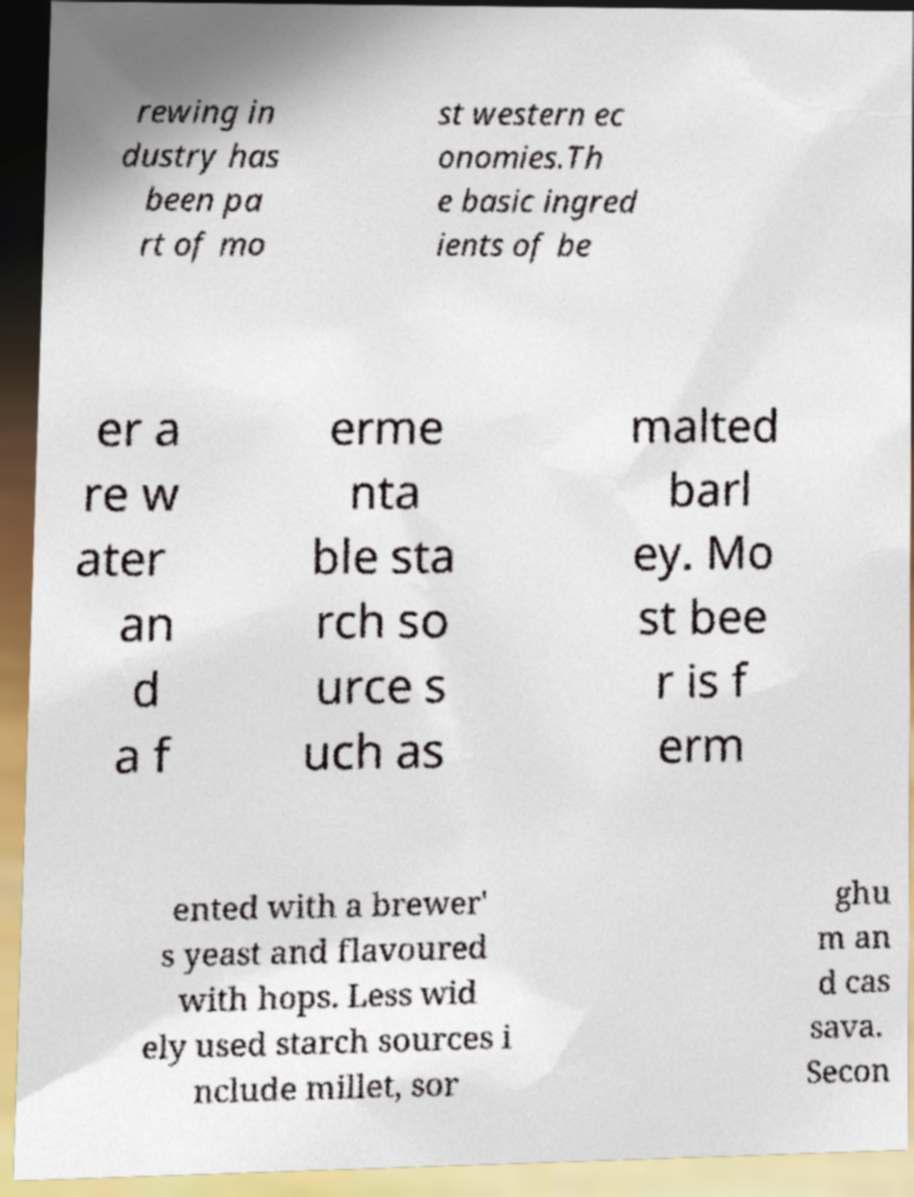Please read and relay the text visible in this image. What does it say? rewing in dustry has been pa rt of mo st western ec onomies.Th e basic ingred ients of be er a re w ater an d a f erme nta ble sta rch so urce s uch as malted barl ey. Mo st bee r is f erm ented with a brewer' s yeast and flavoured with hops. Less wid ely used starch sources i nclude millet, sor ghu m an d cas sava. Secon 